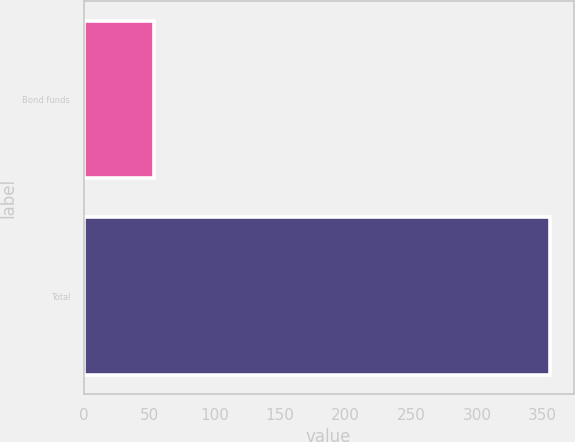<chart> <loc_0><loc_0><loc_500><loc_500><bar_chart><fcel>Bond funds<fcel>Total<nl><fcel>53.6<fcel>356.1<nl></chart> 